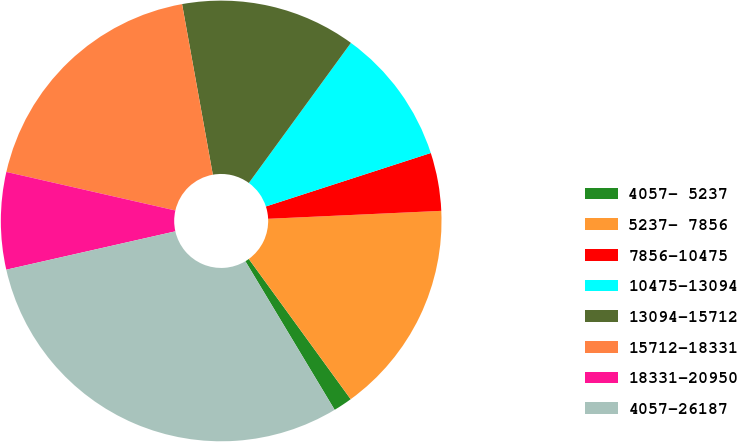Convert chart. <chart><loc_0><loc_0><loc_500><loc_500><pie_chart><fcel>4057- 5237<fcel>5237- 7856<fcel>7856-10475<fcel>10475-13094<fcel>13094-15712<fcel>15712-18331<fcel>18331-20950<fcel>4057-26187<nl><fcel>1.39%<fcel>15.73%<fcel>4.26%<fcel>9.99%<fcel>12.86%<fcel>18.59%<fcel>7.12%<fcel>30.06%<nl></chart> 